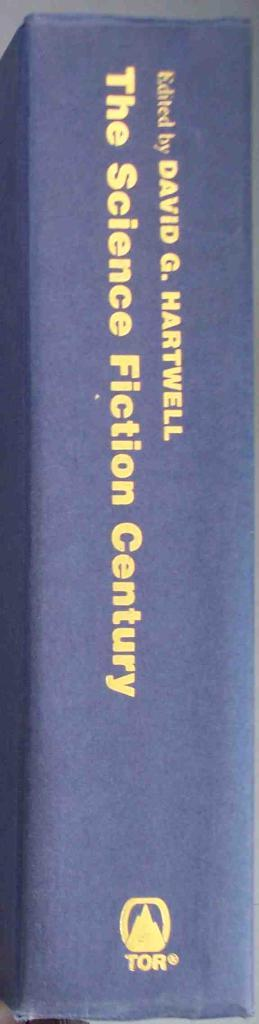<image>
Offer a succinct explanation of the picture presented. The book The Science Fiction Century was edited by David G. Hartwell. 